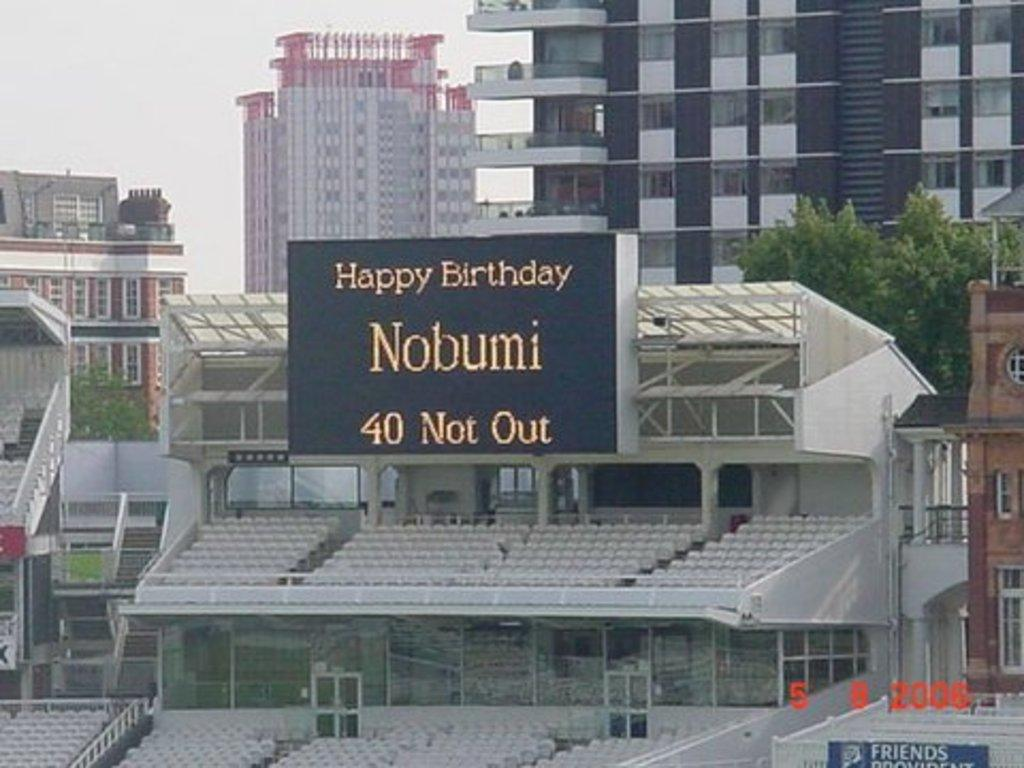<image>
Give a short and clear explanation of the subsequent image. A sign announces Happy birthday Nobumi 40 not out. 